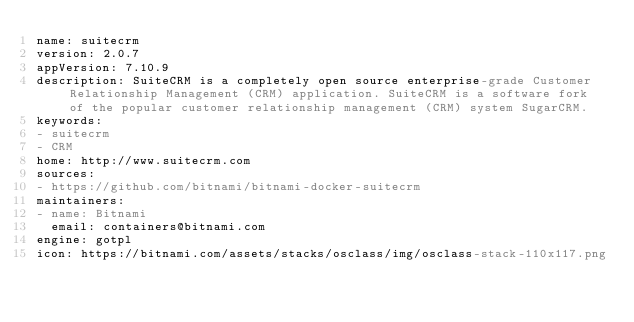<code> <loc_0><loc_0><loc_500><loc_500><_YAML_>name: suitecrm
version: 2.0.7
appVersion: 7.10.9
description: SuiteCRM is a completely open source enterprise-grade Customer Relationship Management (CRM) application. SuiteCRM is a software fork of the popular customer relationship management (CRM) system SugarCRM.
keywords:
- suitecrm
- CRM
home: http://www.suitecrm.com
sources:
- https://github.com/bitnami/bitnami-docker-suitecrm
maintainers:
- name: Bitnami
  email: containers@bitnami.com
engine: gotpl
icon: https://bitnami.com/assets/stacks/osclass/img/osclass-stack-110x117.png
</code> 